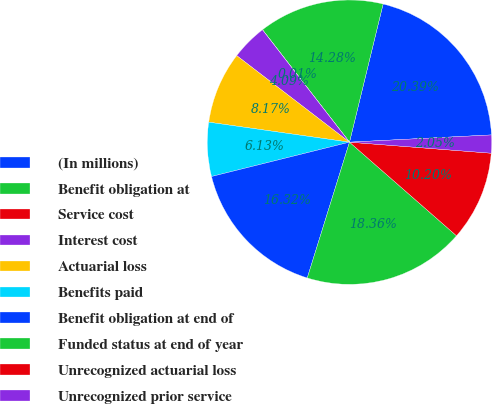Convert chart. <chart><loc_0><loc_0><loc_500><loc_500><pie_chart><fcel>(In millions)<fcel>Benefit obligation at<fcel>Service cost<fcel>Interest cost<fcel>Actuarial loss<fcel>Benefits paid<fcel>Benefit obligation at end of<fcel>Funded status at end of year<fcel>Unrecognized actuarial loss<fcel>Unrecognized prior service<nl><fcel>20.39%<fcel>14.28%<fcel>0.01%<fcel>4.09%<fcel>8.17%<fcel>6.13%<fcel>16.32%<fcel>18.36%<fcel>10.2%<fcel>2.05%<nl></chart> 